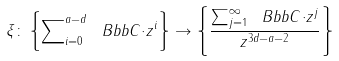Convert formula to latex. <formula><loc_0><loc_0><loc_500><loc_500>\xi \colon \left \{ \sum \nolimits _ { i = 0 } ^ { a - d } \ B b b { C \cdot } z ^ { i } \right \} \rightarrow \left \{ \frac { \sum \nolimits _ { j = 1 } ^ { \infty } \ B b b { C \cdot } z ^ { j } } { z ^ { 3 d - a - 2 } } \right \}</formula> 